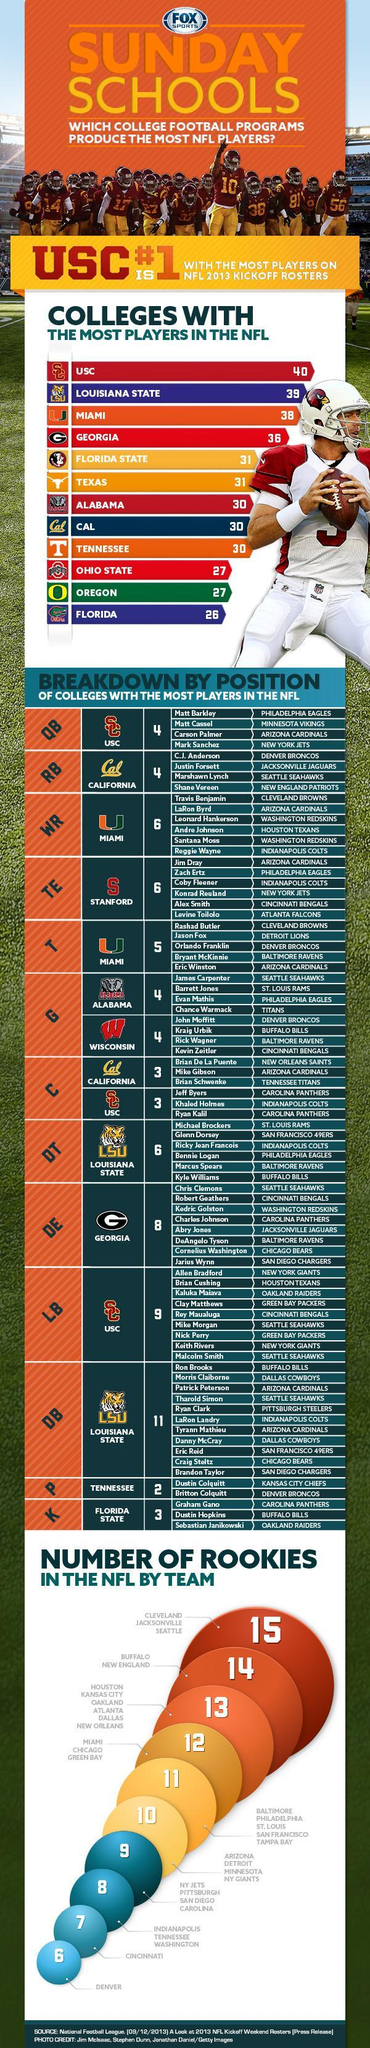What is the total number of players from Miami as Wide receivers and Offensive tacklers?
Answer the question with a short phrase. 11 What is the number of center positions from the Southern California University? 3 What is the total number of players from the Southern California University are participating in NFL? 16 What is total number of rookies in the NFL team from Miami, Chicago and Green Bay? 12 What is the total number of defensive backs and defensive tacklers from LSU? 17 Which college have 31 players each on the NFL 2013 rosters? Florida State, Texas How many players are line backers with Green Bay Packers? 2 How many players from Miami play for Arizona Cardinals as wide receivers or tacklers? 2 How many players play for the Buffalo Bills team? 4 Which players from Carolina Panthers play the center position? Jeff Byers, Ryan Kalil 